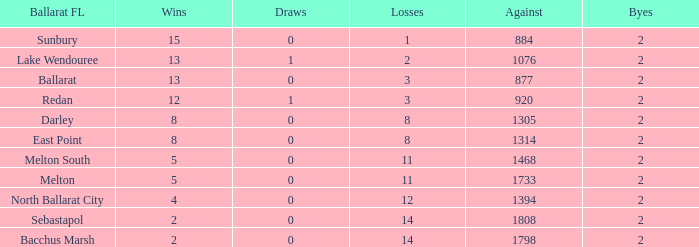How many Against has a Ballarat FL of darley and Wins larger than 8? 0.0. 